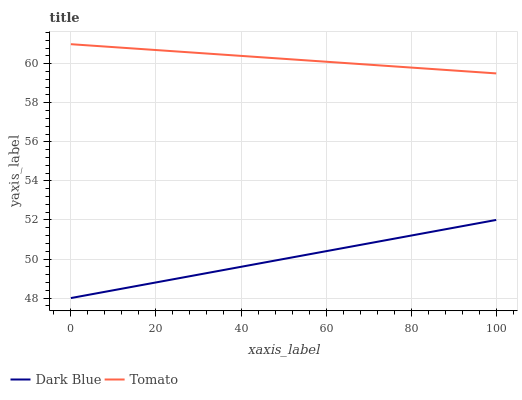Does Dark Blue have the maximum area under the curve?
Answer yes or no. No. Is Dark Blue the roughest?
Answer yes or no. No. Does Dark Blue have the highest value?
Answer yes or no. No. Is Dark Blue less than Tomato?
Answer yes or no. Yes. Is Tomato greater than Dark Blue?
Answer yes or no. Yes. Does Dark Blue intersect Tomato?
Answer yes or no. No. 